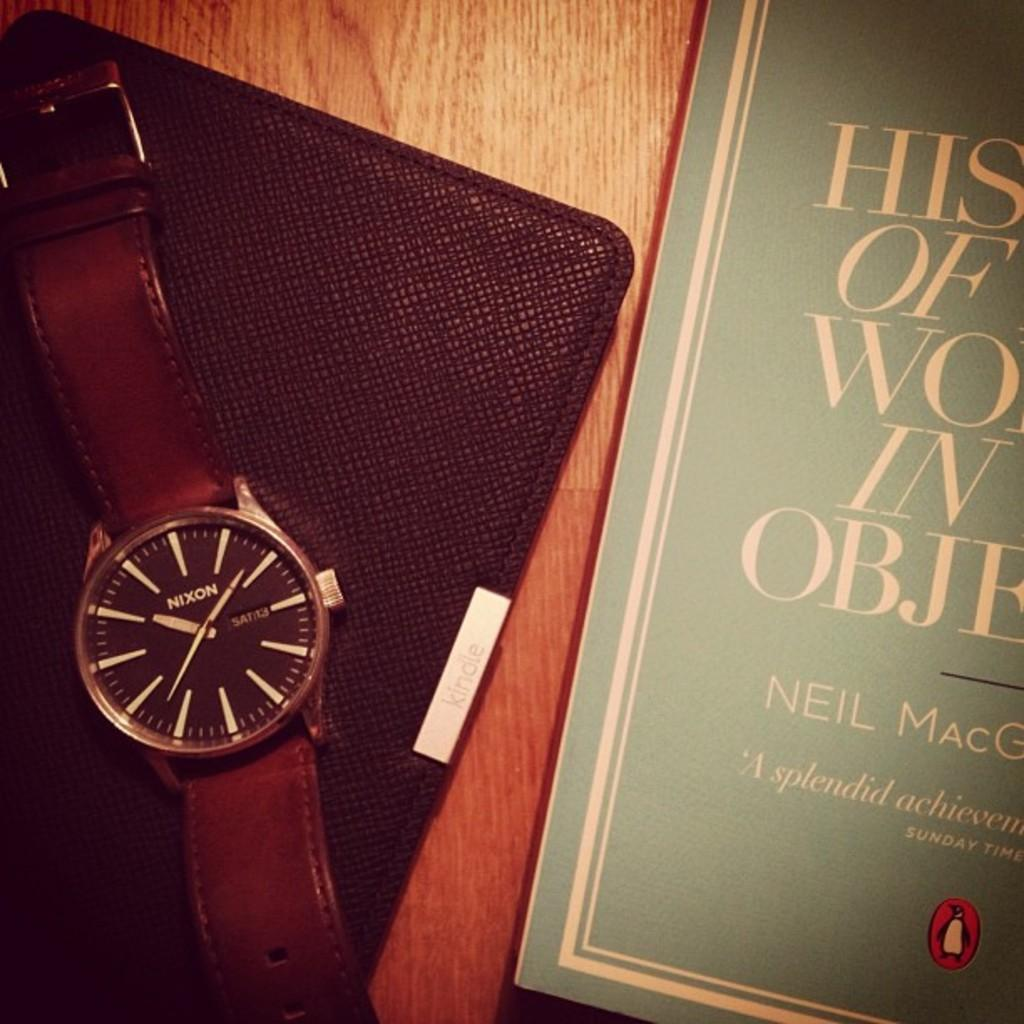<image>
Provide a brief description of the given image. A Nixon wrist watch is next to a book. 